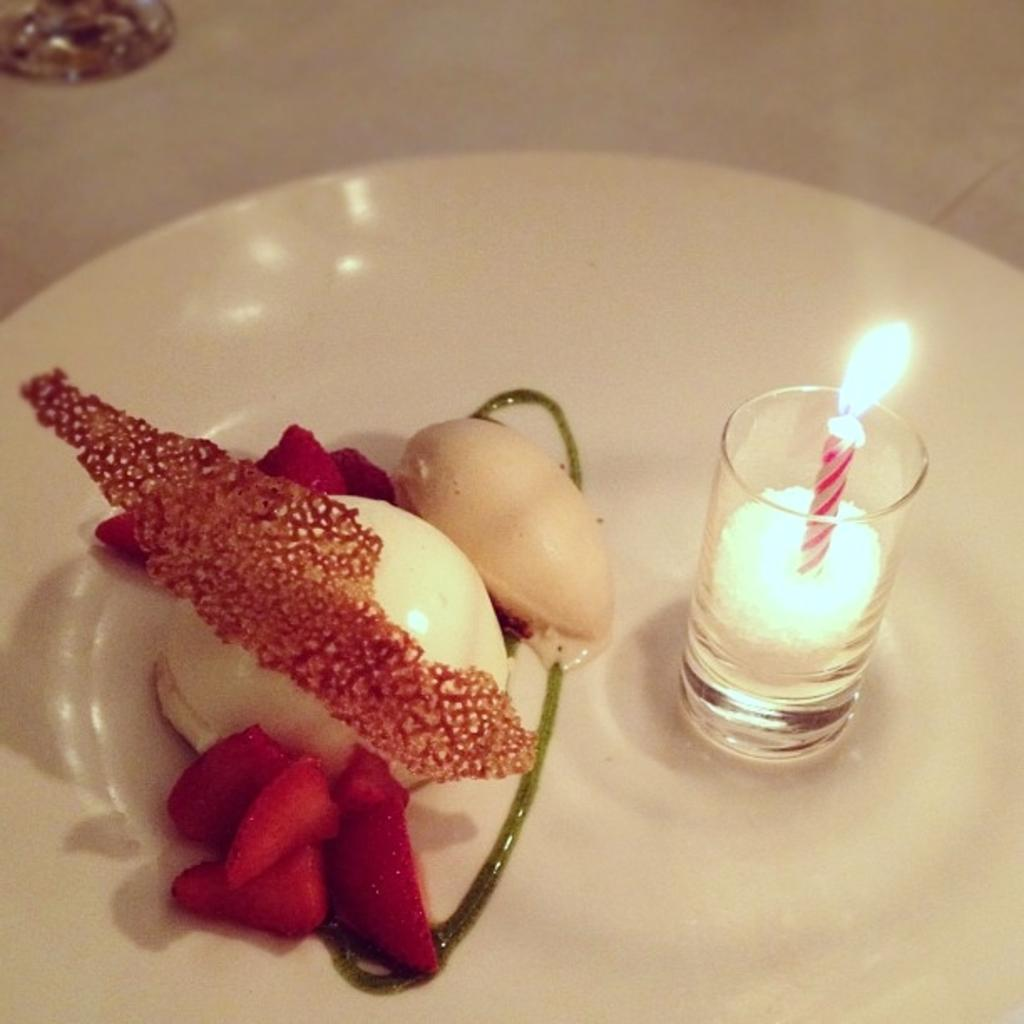What object is present on the plate in the image? There is a plate in the image. What is on top of the plate? There is food on the plate. What other object is on the plate? There is a glass on the plate. What is inside the glass on the plate? There is a candle in the glass. What type of ink can be seen in the image? There is no ink present in the image. What kind of frame is around the plate in the image? There is no frame around the plate in the image. 